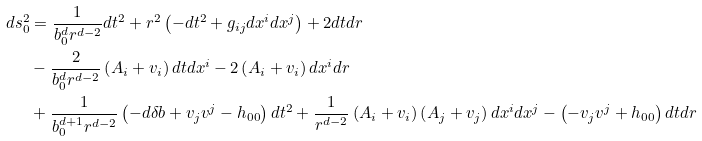Convert formula to latex. <formula><loc_0><loc_0><loc_500><loc_500>d s _ { 0 } ^ { 2 } & = \frac { 1 } { b _ { 0 } ^ { d } r ^ { d - 2 } } d t ^ { 2 } + r ^ { 2 } \left ( - d t ^ { 2 } + g _ { i j } d x ^ { i } d x ^ { j } \right ) + 2 d t d r \\ & - \frac { 2 } { b _ { 0 } ^ { d } r ^ { d - 2 } } \left ( A _ { i } + v _ { i } \right ) d t d x ^ { i } - 2 \left ( A _ { i } + v _ { i } \right ) d x ^ { i } d r \\ & + \frac { 1 } { b _ { 0 } ^ { d + 1 } r ^ { d - 2 } } \left ( - d \delta b + v _ { j } v ^ { j } - h _ { 0 0 } \right ) d t ^ { 2 } + \frac { 1 } { r ^ { d - 2 } } \left ( A _ { i } + v _ { i } \right ) \left ( A _ { j } + v _ { j } \right ) d x ^ { i } d x ^ { j } - \left ( - v _ { j } v ^ { j } + h _ { 0 0 } \right ) d t d r \\</formula> 